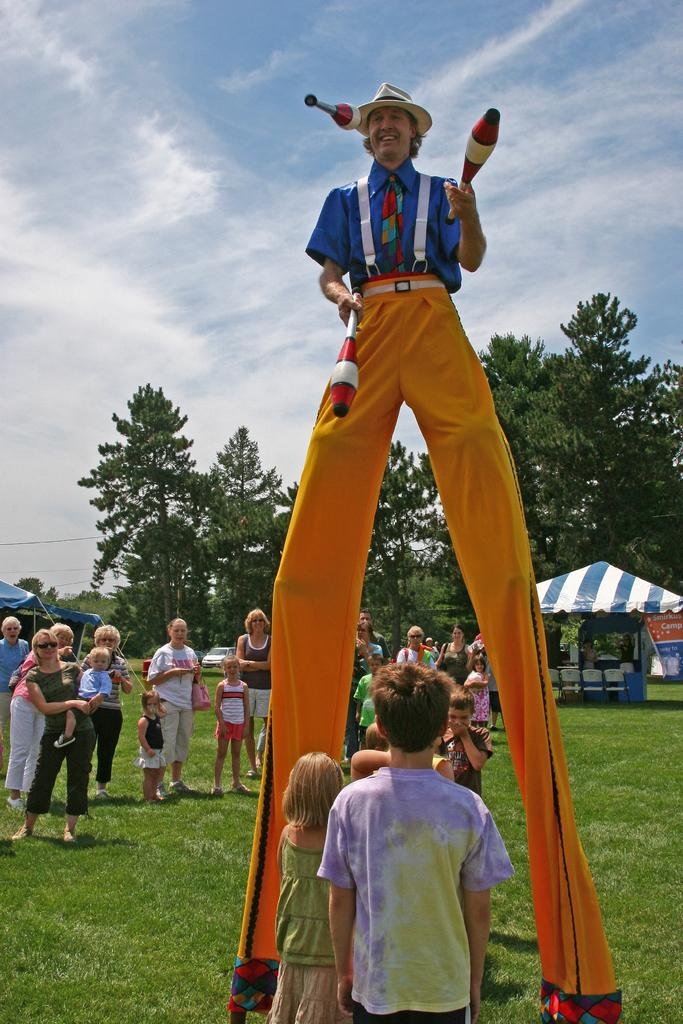What is the main subject of the image? There is a tall joker in the image. What are the people in the image doing? People are standing around the joker and watching the joker's activity. What can be seen in the background of the image? There are many trees and a stall in the background of the image. What type of meal is being served at the honey stall in the image? There is no honey stall present in the image; it features a tall joker and people watching him. What kind of noise is coming from the joker in the image? The image does not provide any information about the noise level or type of noise coming from the joker. 